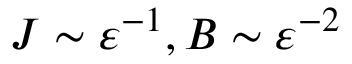Convert formula to latex. <formula><loc_0><loc_0><loc_500><loc_500>J \sim { \varepsilon } ^ { - 1 } , B \sim { \varepsilon } ^ { - 2 }</formula> 